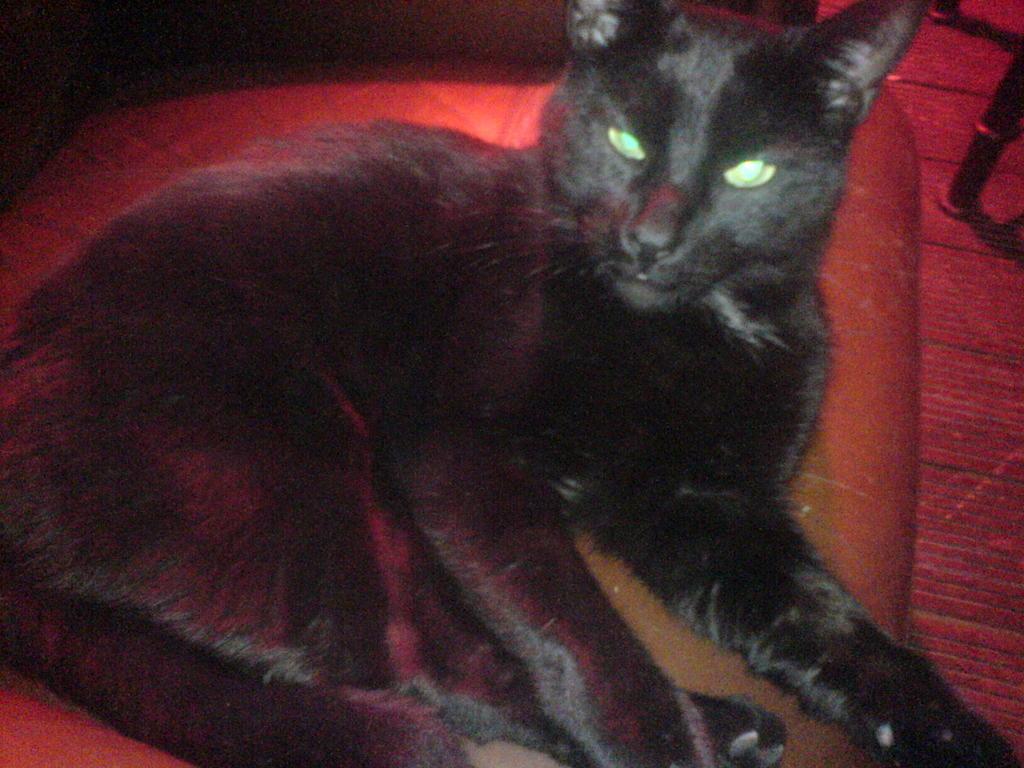How would you summarize this image in a sentence or two? In this picture there is a black cat sitting on the chair. At the bottom there is a mat and there is an object. 